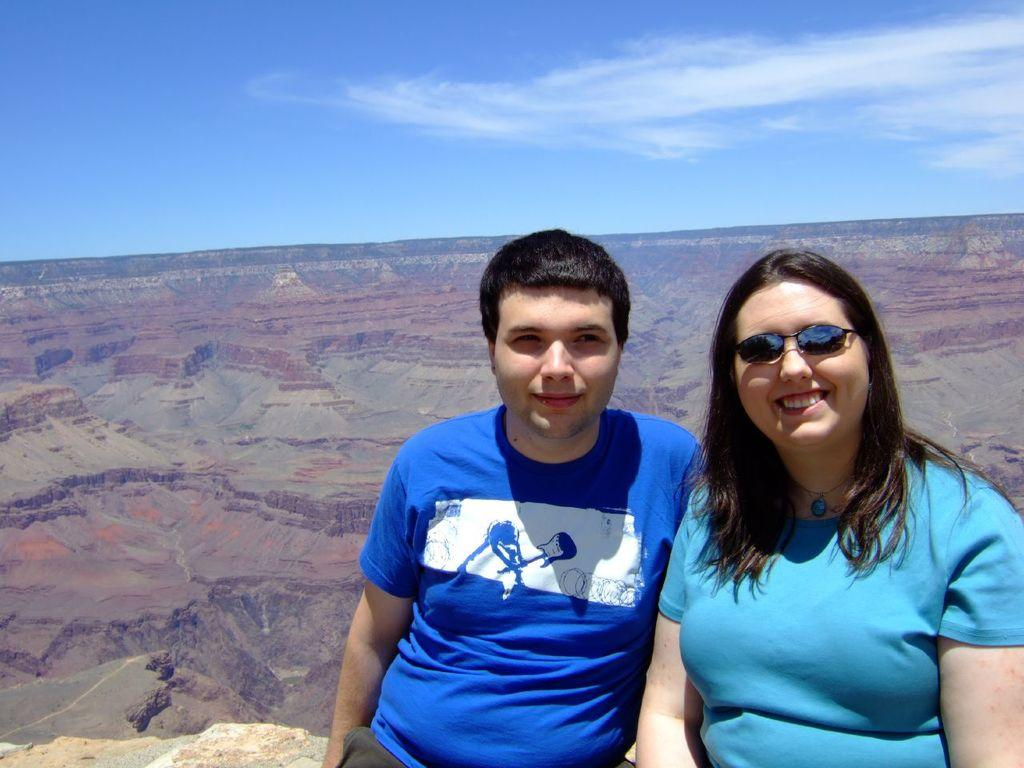Who is present in the image? There is a man and a woman in the image. What are the man and woman doing in the image? The man and woman are sitting on a rock. What is the emotional state of the man and woman in the image? The man and woman are smiling in the image. What is the woman wearing in the image? The woman is wearing sunglasses in the image. What can be seen in the background of the image? There are rocky mountains in the background of the image. What is visible at the top of the image? The sky is visible at the top of the image. What organization is the man and woman attending in the image? There is no indication of an organization in the image; it simply shows a man and woman sitting on a rock. Can you touch the sky in the image? The sky in the image is not a physical object that can be touched; it is a representation of the atmosphere. 